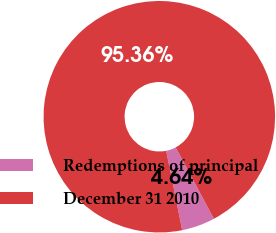Convert chart to OTSL. <chart><loc_0><loc_0><loc_500><loc_500><pie_chart><fcel>Redemptions of principal<fcel>December 31 2010<nl><fcel>4.64%<fcel>95.36%<nl></chart> 